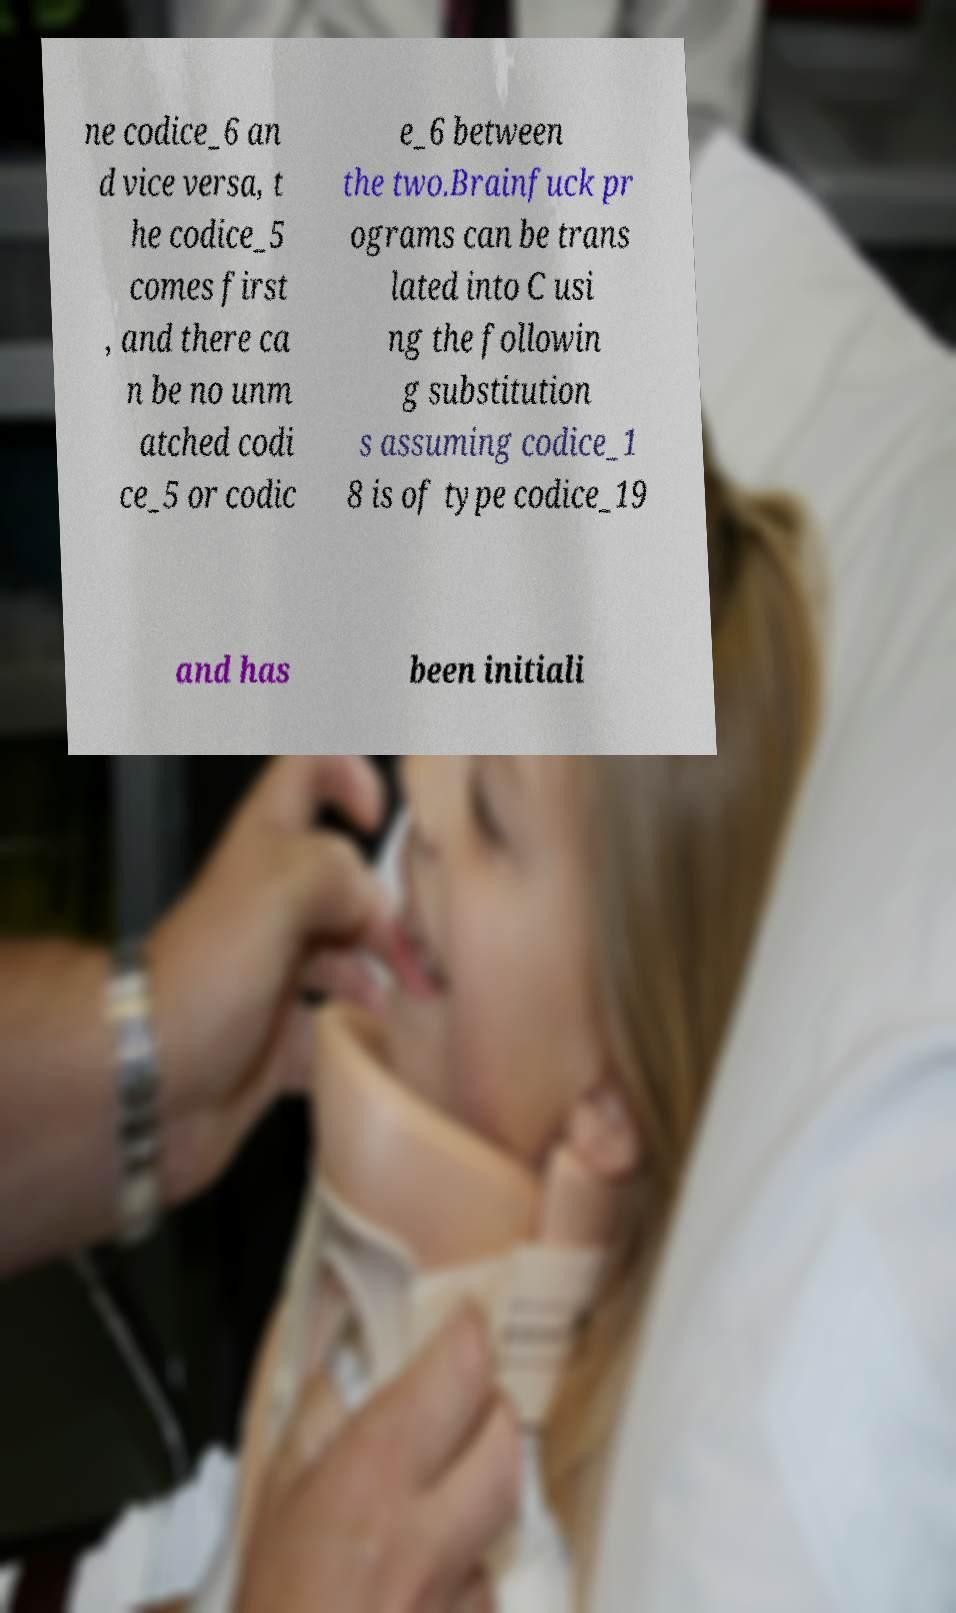Could you assist in decoding the text presented in this image and type it out clearly? ne codice_6 an d vice versa, t he codice_5 comes first , and there ca n be no unm atched codi ce_5 or codic e_6 between the two.Brainfuck pr ograms can be trans lated into C usi ng the followin g substitution s assuming codice_1 8 is of type codice_19 and has been initiali 